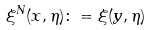Convert formula to latex. <formula><loc_0><loc_0><loc_500><loc_500>\xi ^ { N } ( x , \eta ) \colon = \xi ( y , \eta )</formula> 